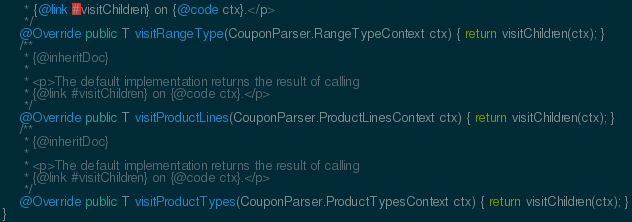<code> <loc_0><loc_0><loc_500><loc_500><_Java_>	 * {@link #visitChildren} on {@code ctx}.</p>
	 */
	@Override public T visitRangeType(CouponParser.RangeTypeContext ctx) { return visitChildren(ctx); }
	/**
	 * {@inheritDoc}
	 *
	 * <p>The default implementation returns the result of calling
	 * {@link #visitChildren} on {@code ctx}.</p>
	 */
	@Override public T visitProductLines(CouponParser.ProductLinesContext ctx) { return visitChildren(ctx); }
	/**
	 * {@inheritDoc}
	 *
	 * <p>The default implementation returns the result of calling
	 * {@link #visitChildren} on {@code ctx}.</p>
	 */
	@Override public T visitProductTypes(CouponParser.ProductTypesContext ctx) { return visitChildren(ctx); }
}</code> 